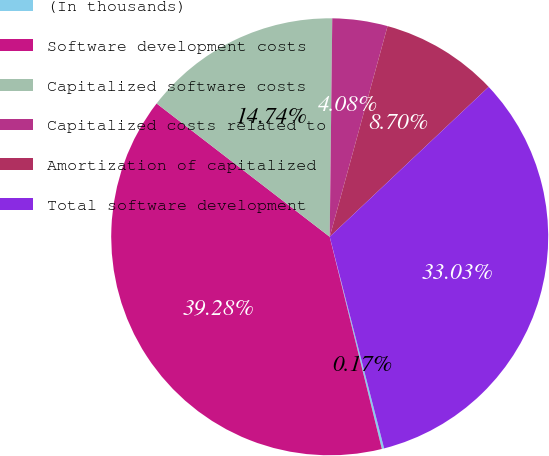<chart> <loc_0><loc_0><loc_500><loc_500><pie_chart><fcel>(In thousands)<fcel>Software development costs<fcel>Capitalized software costs<fcel>Capitalized costs related to<fcel>Amortization of capitalized<fcel>Total software development<nl><fcel>0.17%<fcel>39.28%<fcel>14.74%<fcel>4.08%<fcel>8.7%<fcel>33.03%<nl></chart> 